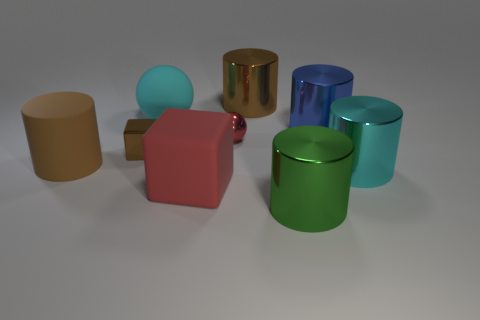Subtract all blue cylinders. How many cylinders are left? 4 Subtract all brown rubber cylinders. How many cylinders are left? 4 Subtract 1 cylinders. How many cylinders are left? 4 Subtract all red cylinders. Subtract all purple balls. How many cylinders are left? 5 Add 1 brown things. How many objects exist? 10 Subtract all blocks. How many objects are left? 7 Subtract 0 brown balls. How many objects are left? 9 Subtract all tiny brown shiny cubes. Subtract all cyan metal cylinders. How many objects are left? 7 Add 5 blue metallic objects. How many blue metallic objects are left? 6 Add 7 large brown metal things. How many large brown metal things exist? 8 